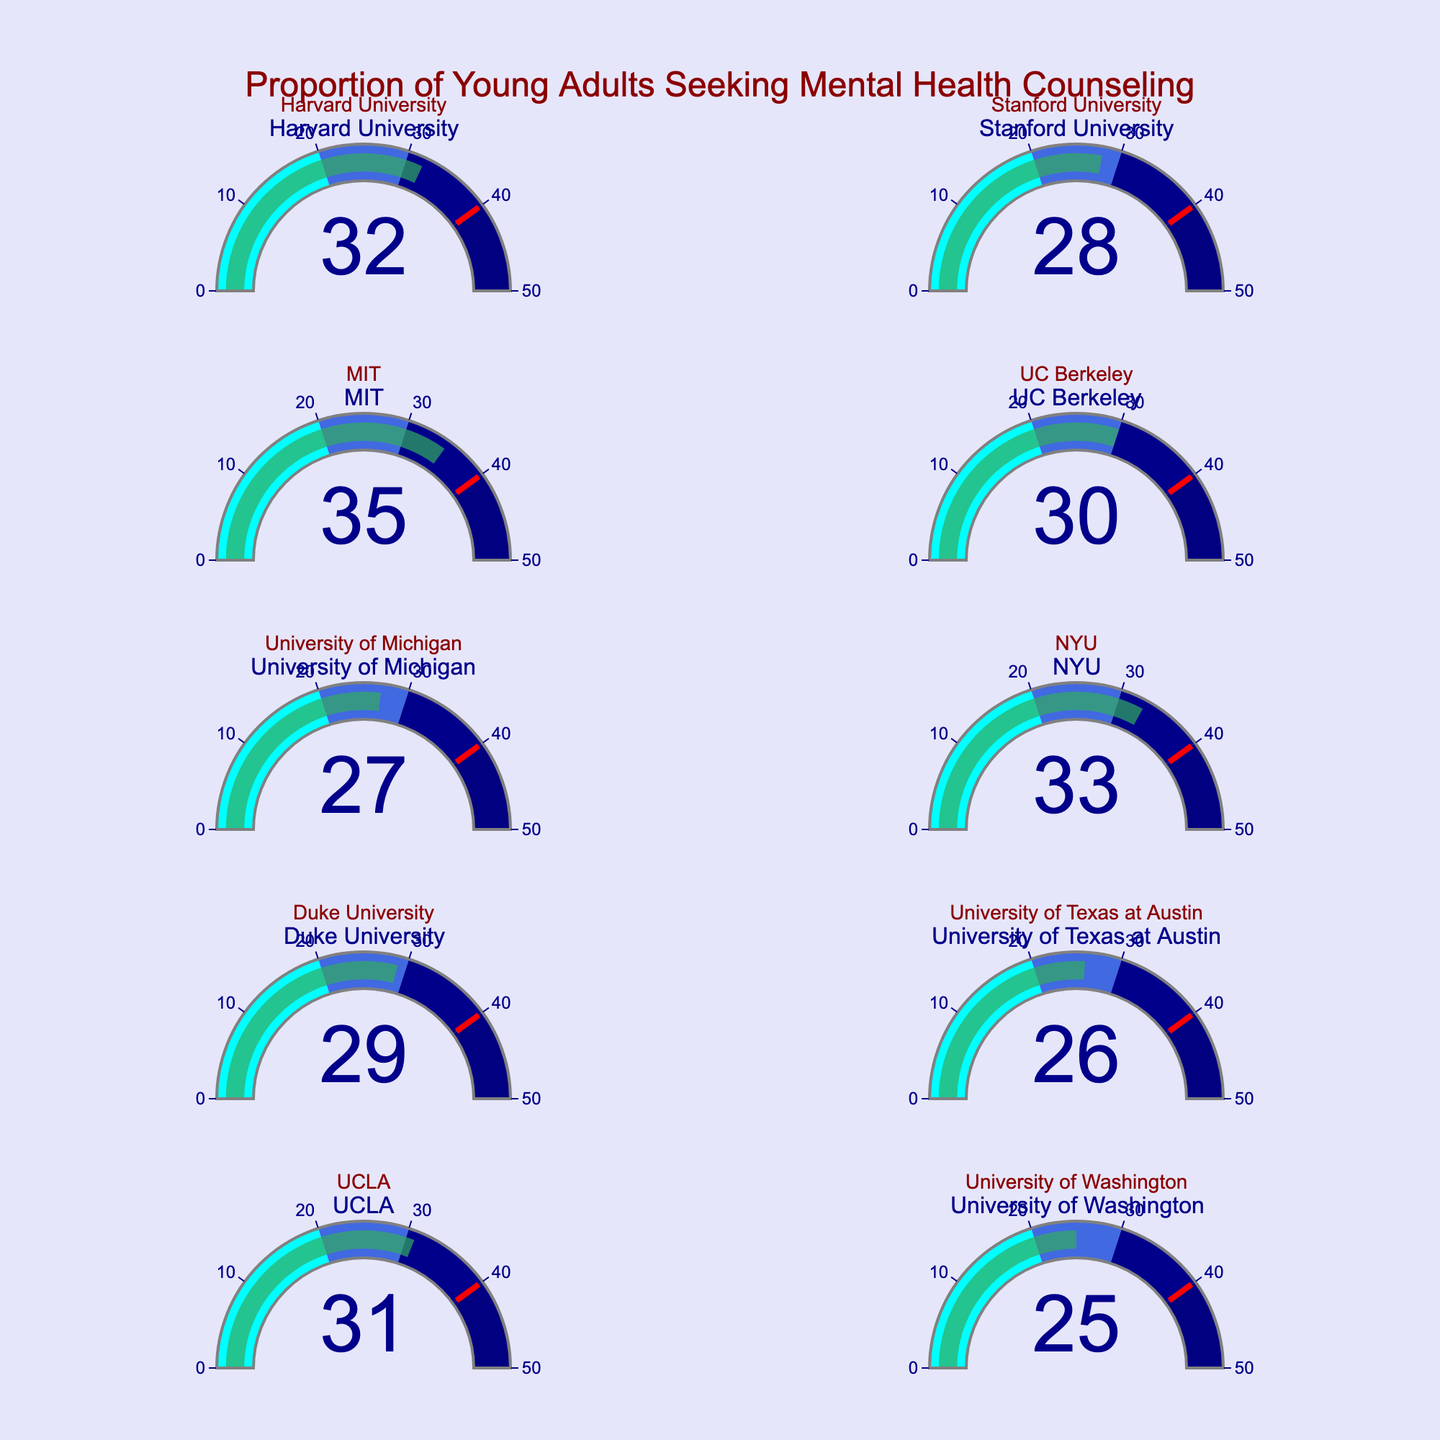what is the title of the figure? The title is located at the top center of the figure and reads "Proportion of Young Adults Seeking Mental Health Counseling." The font is dark red and of large size.
Answer: Proportion of Young Adults Seeking Mental Health Counseling How many universities are represented in the figure? By counting the number of gauges shown, it is visible that there are 10 gauges, each representing a separate university.
Answer: 10 What is the gauge color for a percentage in the range of 0-20%? The gauge color for a percentage value in the range of 0-20% is cyan. This can be identified by observing the color legend within the gauge.
Answer: Cyan Which university has the highest proportion of students seeking mental health counseling? By examining the values displayed on the gauges, MIT has the highest proportion of students with 35%.
Answer: MIT Which universities have proportions of students seeking mental health counseling greater than 30%? The universities with gauge values greater than 30% are Harvard University (32%), MIT (35%), NYU (33%), and UCLA (31%).
Answer: Harvard University, MIT, NYU, UCLA What is the combined proportion of students seeking mental health counseling at Harvard University and Stanford University? Harvard University has 32% and Stanford University has 28%. Adding these together, 32% + 28% = 60%.
Answer: 60% What is the average proportion of students seeking mental health counseling across the universities? Sum each percentage: 32 + 28 + 35 + 30 + 27 + 33 + 29 + 26 + 31 + 25 = 296. Divide by the number of universities, which is 10. So, 296 / 10 = 29.6%.
Answer: 29.6% Which university is just below the threshold of 30%? Since the threshold for 30% is marked on the gauge, the university just below it with 29% is Duke University.
Answer: Duke University What is the color of the bar on the gauges? The bar color on each gauge, which represents the proportion of students seeking mental health counseling, is a shade of green (specifically, it is close to rgba(50, 171, 96, 0.7)).
Answer: Green 